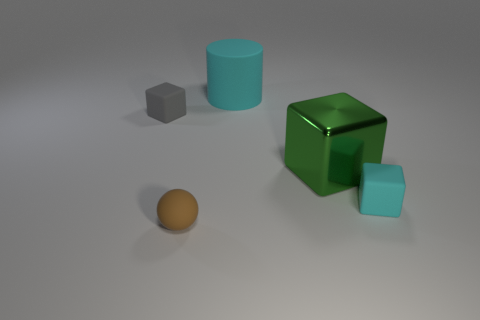What size is the cyan matte object that is behind the small gray object?
Offer a very short reply. Large. What material is the large cyan object?
Give a very brief answer. Rubber. There is a cyan rubber object right of the cylinder; is it the same shape as the gray object?
Your answer should be very brief. Yes. There is a rubber cube that is the same color as the rubber cylinder; what size is it?
Provide a succinct answer. Small. Are there any cyan objects of the same size as the green metallic block?
Give a very brief answer. Yes. Are there any matte things that are right of the green thing behind the cyan object in front of the big cyan object?
Provide a succinct answer. Yes. Do the large rubber cylinder and the tiny block that is to the right of the big green cube have the same color?
Offer a terse response. Yes. The tiny cube that is to the right of the small block that is left of the rubber thing behind the gray object is made of what material?
Your answer should be very brief. Rubber. What shape is the small rubber object to the right of the green block?
Give a very brief answer. Cube. The cylinder that is the same material as the small sphere is what size?
Your answer should be very brief. Large. 